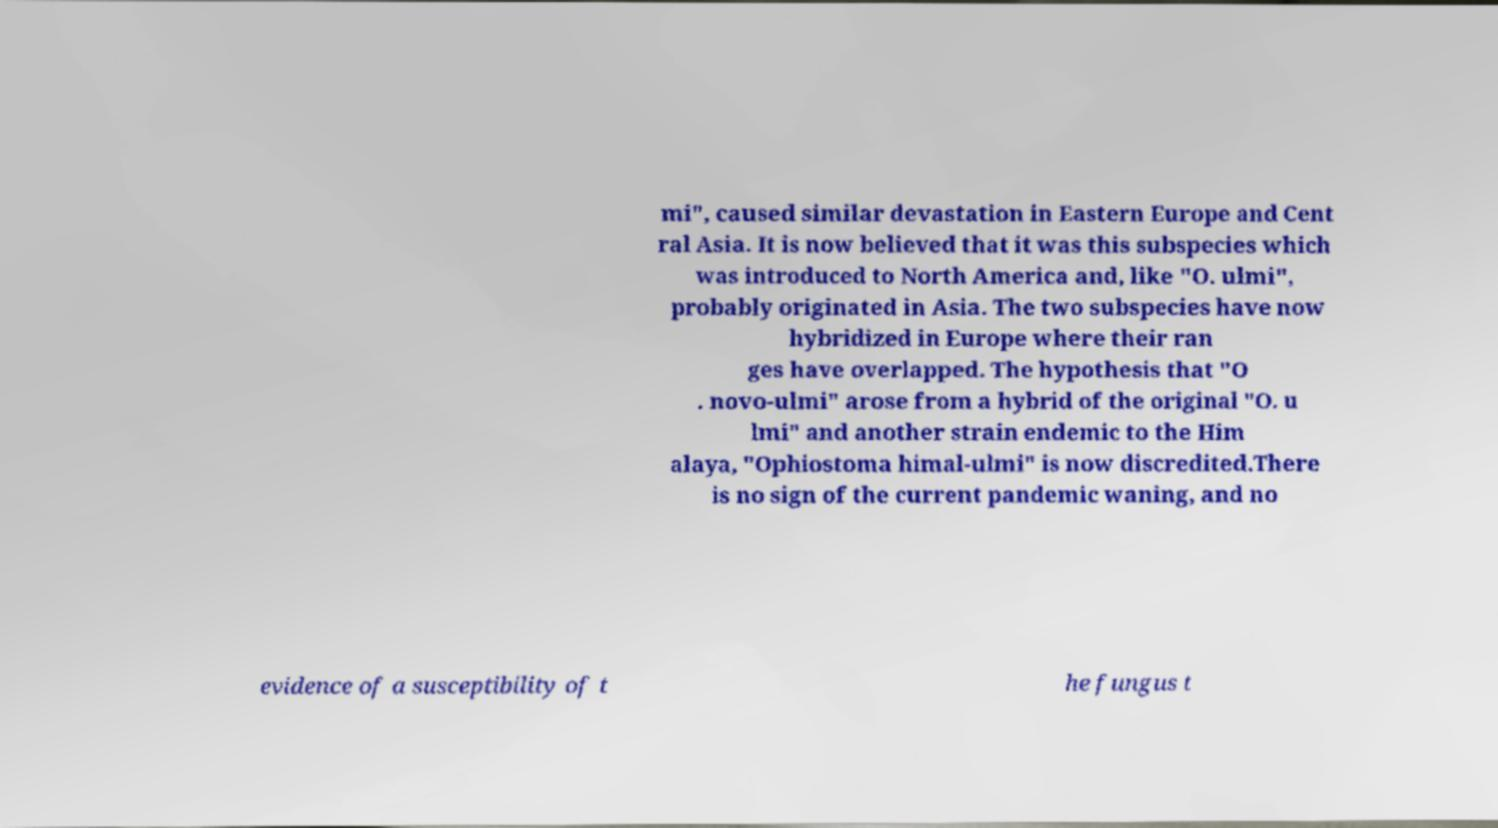Could you assist in decoding the text presented in this image and type it out clearly? mi", caused similar devastation in Eastern Europe and Cent ral Asia. It is now believed that it was this subspecies which was introduced to North America and, like "O. ulmi", probably originated in Asia. The two subspecies have now hybridized in Europe where their ran ges have overlapped. The hypothesis that "O . novo-ulmi" arose from a hybrid of the original "O. u lmi" and another strain endemic to the Him alaya, "Ophiostoma himal-ulmi" is now discredited.There is no sign of the current pandemic waning, and no evidence of a susceptibility of t he fungus t 